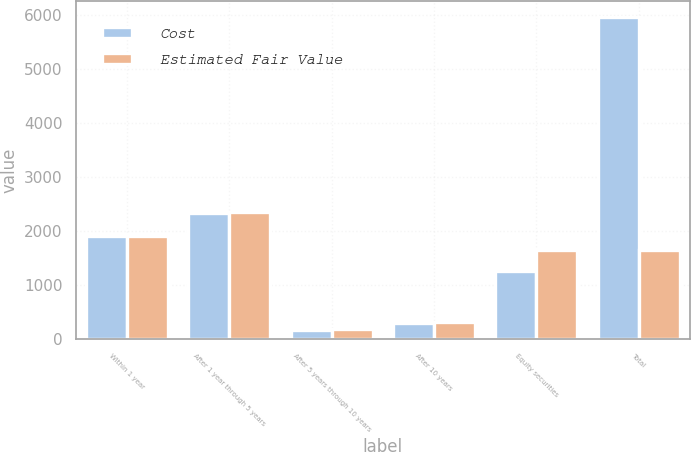<chart> <loc_0><loc_0><loc_500><loc_500><stacked_bar_chart><ecel><fcel>Within 1 year<fcel>After 1 year through 5 years<fcel>After 5 years through 10 years<fcel>After 10 years<fcel>Equity securities<fcel>Total<nl><fcel>Cost<fcel>1900<fcel>2324<fcel>176<fcel>300<fcel>1252<fcel>5952<nl><fcel>Estimated Fair Value<fcel>1900<fcel>2352<fcel>194<fcel>312<fcel>1655<fcel>1655<nl></chart> 